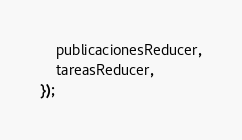<code> <loc_0><loc_0><loc_500><loc_500><_JavaScript_>    publicacionesReducer,
    tareasReducer,
});</code> 